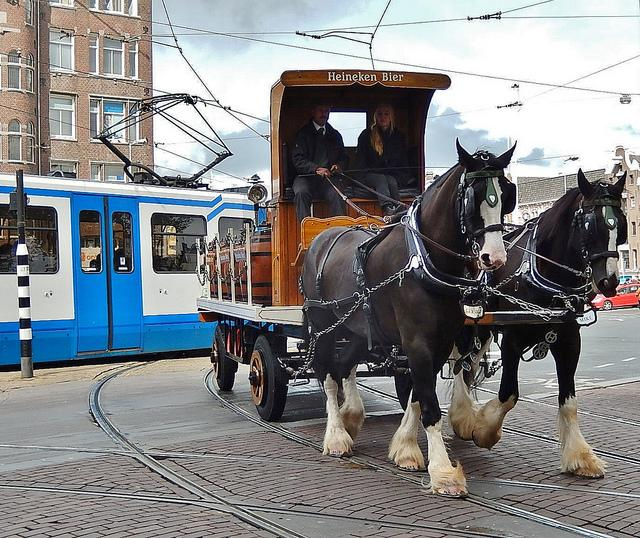What sort of product do ad men use these type horses to market? Please explain your reasoning. beer. That is a well known german beer 